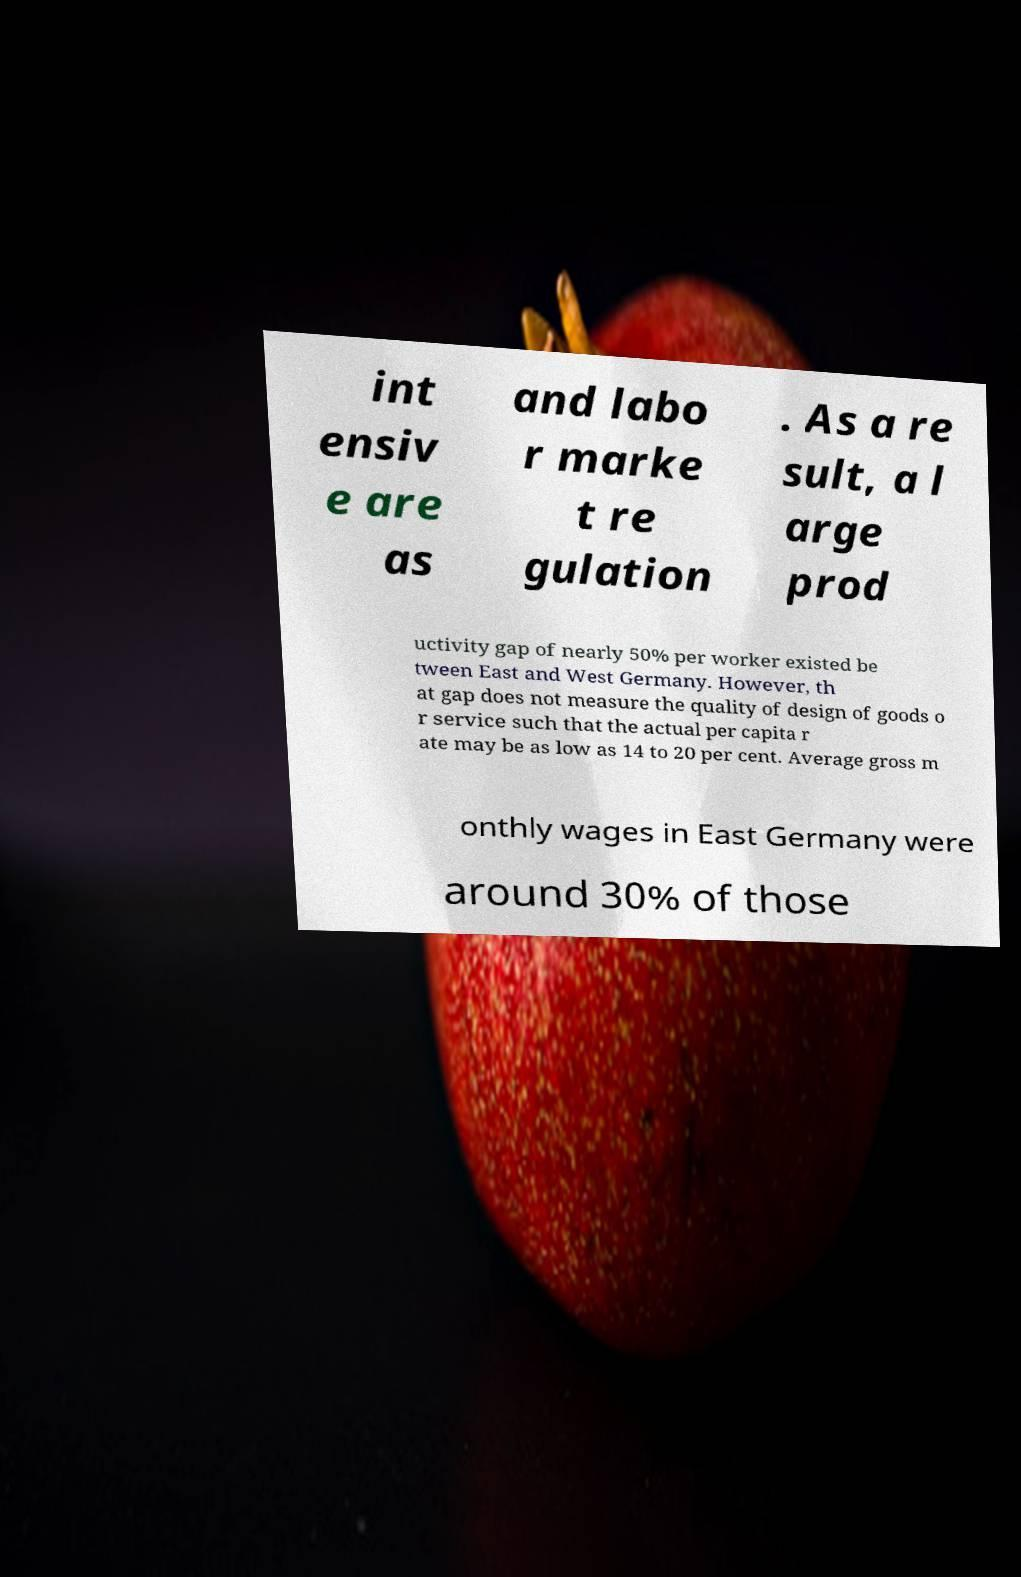Could you extract and type out the text from this image? int ensiv e are as and labo r marke t re gulation . As a re sult, a l arge prod uctivity gap of nearly 50% per worker existed be tween East and West Germany. However, th at gap does not measure the quality of design of goods o r service such that the actual per capita r ate may be as low as 14 to 20 per cent. Average gross m onthly wages in East Germany were around 30% of those 